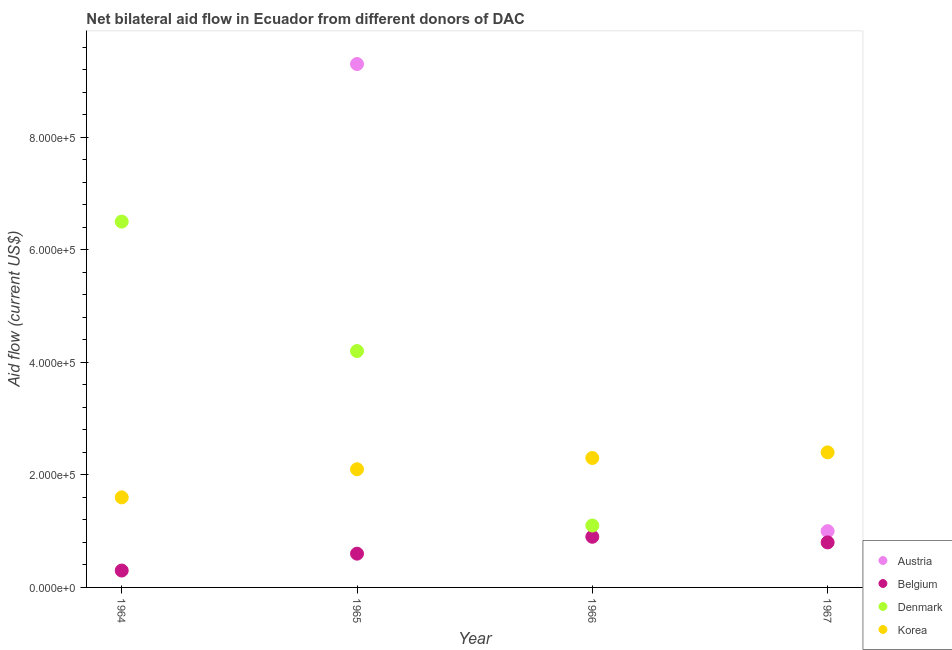What is the amount of aid given by austria in 1966?
Give a very brief answer. 0. Across all years, what is the maximum amount of aid given by austria?
Your response must be concise. 9.30e+05. In which year was the amount of aid given by austria maximum?
Provide a succinct answer. 1965. What is the total amount of aid given by belgium in the graph?
Make the answer very short. 2.60e+05. What is the difference between the amount of aid given by austria in 1965 and that in 1967?
Offer a very short reply. 8.30e+05. What is the difference between the amount of aid given by korea in 1966 and the amount of aid given by austria in 1965?
Ensure brevity in your answer.  -7.00e+05. What is the average amount of aid given by belgium per year?
Provide a short and direct response. 6.50e+04. In the year 1966, what is the difference between the amount of aid given by belgium and amount of aid given by denmark?
Provide a short and direct response. -2.00e+04. What is the ratio of the amount of aid given by korea in 1964 to that in 1965?
Give a very brief answer. 0.76. Is the amount of aid given by korea in 1964 less than that in 1966?
Keep it short and to the point. Yes. Is the difference between the amount of aid given by korea in 1965 and 1966 greater than the difference between the amount of aid given by denmark in 1965 and 1966?
Your answer should be very brief. No. What is the difference between the highest and the lowest amount of aid given by denmark?
Make the answer very short. 6.50e+05. In how many years, is the amount of aid given by korea greater than the average amount of aid given by korea taken over all years?
Offer a very short reply. 2. Is the sum of the amount of aid given by austria in 1965 and 1967 greater than the maximum amount of aid given by belgium across all years?
Keep it short and to the point. Yes. Is it the case that in every year, the sum of the amount of aid given by austria and amount of aid given by korea is greater than the sum of amount of aid given by denmark and amount of aid given by belgium?
Provide a succinct answer. No. Is it the case that in every year, the sum of the amount of aid given by austria and amount of aid given by belgium is greater than the amount of aid given by denmark?
Ensure brevity in your answer.  No. Does the amount of aid given by austria monotonically increase over the years?
Provide a succinct answer. No. Is the amount of aid given by austria strictly greater than the amount of aid given by denmark over the years?
Offer a terse response. No. Is the amount of aid given by korea strictly less than the amount of aid given by belgium over the years?
Provide a short and direct response. No. How many dotlines are there?
Provide a succinct answer. 4. What is the difference between two consecutive major ticks on the Y-axis?
Your answer should be compact. 2.00e+05. Are the values on the major ticks of Y-axis written in scientific E-notation?
Your answer should be very brief. Yes. Where does the legend appear in the graph?
Offer a very short reply. Bottom right. How many legend labels are there?
Keep it short and to the point. 4. How are the legend labels stacked?
Ensure brevity in your answer.  Vertical. What is the title of the graph?
Provide a short and direct response. Net bilateral aid flow in Ecuador from different donors of DAC. Does "Secondary general education" appear as one of the legend labels in the graph?
Offer a very short reply. No. What is the label or title of the Y-axis?
Make the answer very short. Aid flow (current US$). What is the Aid flow (current US$) in Austria in 1964?
Your answer should be very brief. 0. What is the Aid flow (current US$) of Denmark in 1964?
Your response must be concise. 6.50e+05. What is the Aid flow (current US$) of Korea in 1964?
Make the answer very short. 1.60e+05. What is the Aid flow (current US$) of Austria in 1965?
Your answer should be very brief. 9.30e+05. What is the Aid flow (current US$) in Denmark in 1965?
Offer a very short reply. 4.20e+05. What is the Aid flow (current US$) of Denmark in 1966?
Give a very brief answer. 1.10e+05. What is the Aid flow (current US$) of Korea in 1966?
Provide a succinct answer. 2.30e+05. What is the Aid flow (current US$) of Austria in 1967?
Offer a very short reply. 1.00e+05. What is the Aid flow (current US$) of Belgium in 1967?
Keep it short and to the point. 8.00e+04. Across all years, what is the maximum Aid flow (current US$) of Austria?
Give a very brief answer. 9.30e+05. Across all years, what is the maximum Aid flow (current US$) in Denmark?
Your response must be concise. 6.50e+05. Across all years, what is the maximum Aid flow (current US$) in Korea?
Offer a terse response. 2.40e+05. What is the total Aid flow (current US$) in Austria in the graph?
Make the answer very short. 1.03e+06. What is the total Aid flow (current US$) of Denmark in the graph?
Offer a very short reply. 1.18e+06. What is the total Aid flow (current US$) in Korea in the graph?
Offer a very short reply. 8.40e+05. What is the difference between the Aid flow (current US$) of Belgium in 1964 and that in 1965?
Ensure brevity in your answer.  -3.00e+04. What is the difference between the Aid flow (current US$) in Denmark in 1964 and that in 1966?
Your answer should be compact. 5.40e+05. What is the difference between the Aid flow (current US$) in Belgium in 1964 and that in 1967?
Give a very brief answer. -5.00e+04. What is the difference between the Aid flow (current US$) in Korea in 1964 and that in 1967?
Provide a succinct answer. -8.00e+04. What is the difference between the Aid flow (current US$) of Denmark in 1965 and that in 1966?
Your response must be concise. 3.10e+05. What is the difference between the Aid flow (current US$) in Austria in 1965 and that in 1967?
Offer a terse response. 8.30e+05. What is the difference between the Aid flow (current US$) in Belgium in 1965 and that in 1967?
Make the answer very short. -2.00e+04. What is the difference between the Aid flow (current US$) in Korea in 1966 and that in 1967?
Your answer should be very brief. -10000. What is the difference between the Aid flow (current US$) in Belgium in 1964 and the Aid flow (current US$) in Denmark in 1965?
Offer a terse response. -3.90e+05. What is the difference between the Aid flow (current US$) in Denmark in 1964 and the Aid flow (current US$) in Korea in 1966?
Give a very brief answer. 4.20e+05. What is the difference between the Aid flow (current US$) of Belgium in 1964 and the Aid flow (current US$) of Korea in 1967?
Offer a terse response. -2.10e+05. What is the difference between the Aid flow (current US$) of Denmark in 1964 and the Aid flow (current US$) of Korea in 1967?
Make the answer very short. 4.10e+05. What is the difference between the Aid flow (current US$) of Austria in 1965 and the Aid flow (current US$) of Belgium in 1966?
Give a very brief answer. 8.40e+05. What is the difference between the Aid flow (current US$) of Austria in 1965 and the Aid flow (current US$) of Denmark in 1966?
Keep it short and to the point. 8.20e+05. What is the difference between the Aid flow (current US$) of Austria in 1965 and the Aid flow (current US$) of Belgium in 1967?
Your response must be concise. 8.50e+05. What is the difference between the Aid flow (current US$) of Austria in 1965 and the Aid flow (current US$) of Korea in 1967?
Your answer should be compact. 6.90e+05. What is the difference between the Aid flow (current US$) in Belgium in 1965 and the Aid flow (current US$) in Korea in 1967?
Your answer should be compact. -1.80e+05. What is the difference between the Aid flow (current US$) in Belgium in 1966 and the Aid flow (current US$) in Korea in 1967?
Provide a short and direct response. -1.50e+05. What is the difference between the Aid flow (current US$) of Denmark in 1966 and the Aid flow (current US$) of Korea in 1967?
Provide a short and direct response. -1.30e+05. What is the average Aid flow (current US$) of Austria per year?
Your response must be concise. 2.58e+05. What is the average Aid flow (current US$) of Belgium per year?
Your answer should be compact. 6.50e+04. What is the average Aid flow (current US$) of Denmark per year?
Offer a terse response. 2.95e+05. In the year 1964, what is the difference between the Aid flow (current US$) of Belgium and Aid flow (current US$) of Denmark?
Give a very brief answer. -6.20e+05. In the year 1964, what is the difference between the Aid flow (current US$) of Belgium and Aid flow (current US$) of Korea?
Keep it short and to the point. -1.30e+05. In the year 1965, what is the difference between the Aid flow (current US$) of Austria and Aid flow (current US$) of Belgium?
Provide a short and direct response. 8.70e+05. In the year 1965, what is the difference between the Aid flow (current US$) of Austria and Aid flow (current US$) of Denmark?
Ensure brevity in your answer.  5.10e+05. In the year 1965, what is the difference between the Aid flow (current US$) in Austria and Aid flow (current US$) in Korea?
Your answer should be very brief. 7.20e+05. In the year 1965, what is the difference between the Aid flow (current US$) in Belgium and Aid flow (current US$) in Denmark?
Offer a terse response. -3.60e+05. In the year 1966, what is the difference between the Aid flow (current US$) of Belgium and Aid flow (current US$) of Denmark?
Offer a very short reply. -2.00e+04. In the year 1966, what is the difference between the Aid flow (current US$) of Belgium and Aid flow (current US$) of Korea?
Provide a short and direct response. -1.40e+05. What is the ratio of the Aid flow (current US$) in Belgium in 1964 to that in 1965?
Provide a succinct answer. 0.5. What is the ratio of the Aid flow (current US$) of Denmark in 1964 to that in 1965?
Make the answer very short. 1.55. What is the ratio of the Aid flow (current US$) in Korea in 1964 to that in 1965?
Provide a succinct answer. 0.76. What is the ratio of the Aid flow (current US$) of Denmark in 1964 to that in 1966?
Offer a very short reply. 5.91. What is the ratio of the Aid flow (current US$) in Korea in 1964 to that in 1966?
Provide a succinct answer. 0.7. What is the ratio of the Aid flow (current US$) in Belgium in 1964 to that in 1967?
Your answer should be very brief. 0.38. What is the ratio of the Aid flow (current US$) of Korea in 1964 to that in 1967?
Ensure brevity in your answer.  0.67. What is the ratio of the Aid flow (current US$) in Belgium in 1965 to that in 1966?
Offer a very short reply. 0.67. What is the ratio of the Aid flow (current US$) of Denmark in 1965 to that in 1966?
Ensure brevity in your answer.  3.82. What is the ratio of the Aid flow (current US$) of Belgium in 1965 to that in 1967?
Your answer should be very brief. 0.75. What is the ratio of the Aid flow (current US$) of Belgium in 1966 to that in 1967?
Provide a short and direct response. 1.12. What is the ratio of the Aid flow (current US$) in Korea in 1966 to that in 1967?
Your answer should be very brief. 0.96. What is the difference between the highest and the second highest Aid flow (current US$) of Belgium?
Your response must be concise. 10000. What is the difference between the highest and the lowest Aid flow (current US$) in Austria?
Your answer should be compact. 9.30e+05. What is the difference between the highest and the lowest Aid flow (current US$) of Denmark?
Your answer should be very brief. 6.50e+05. 